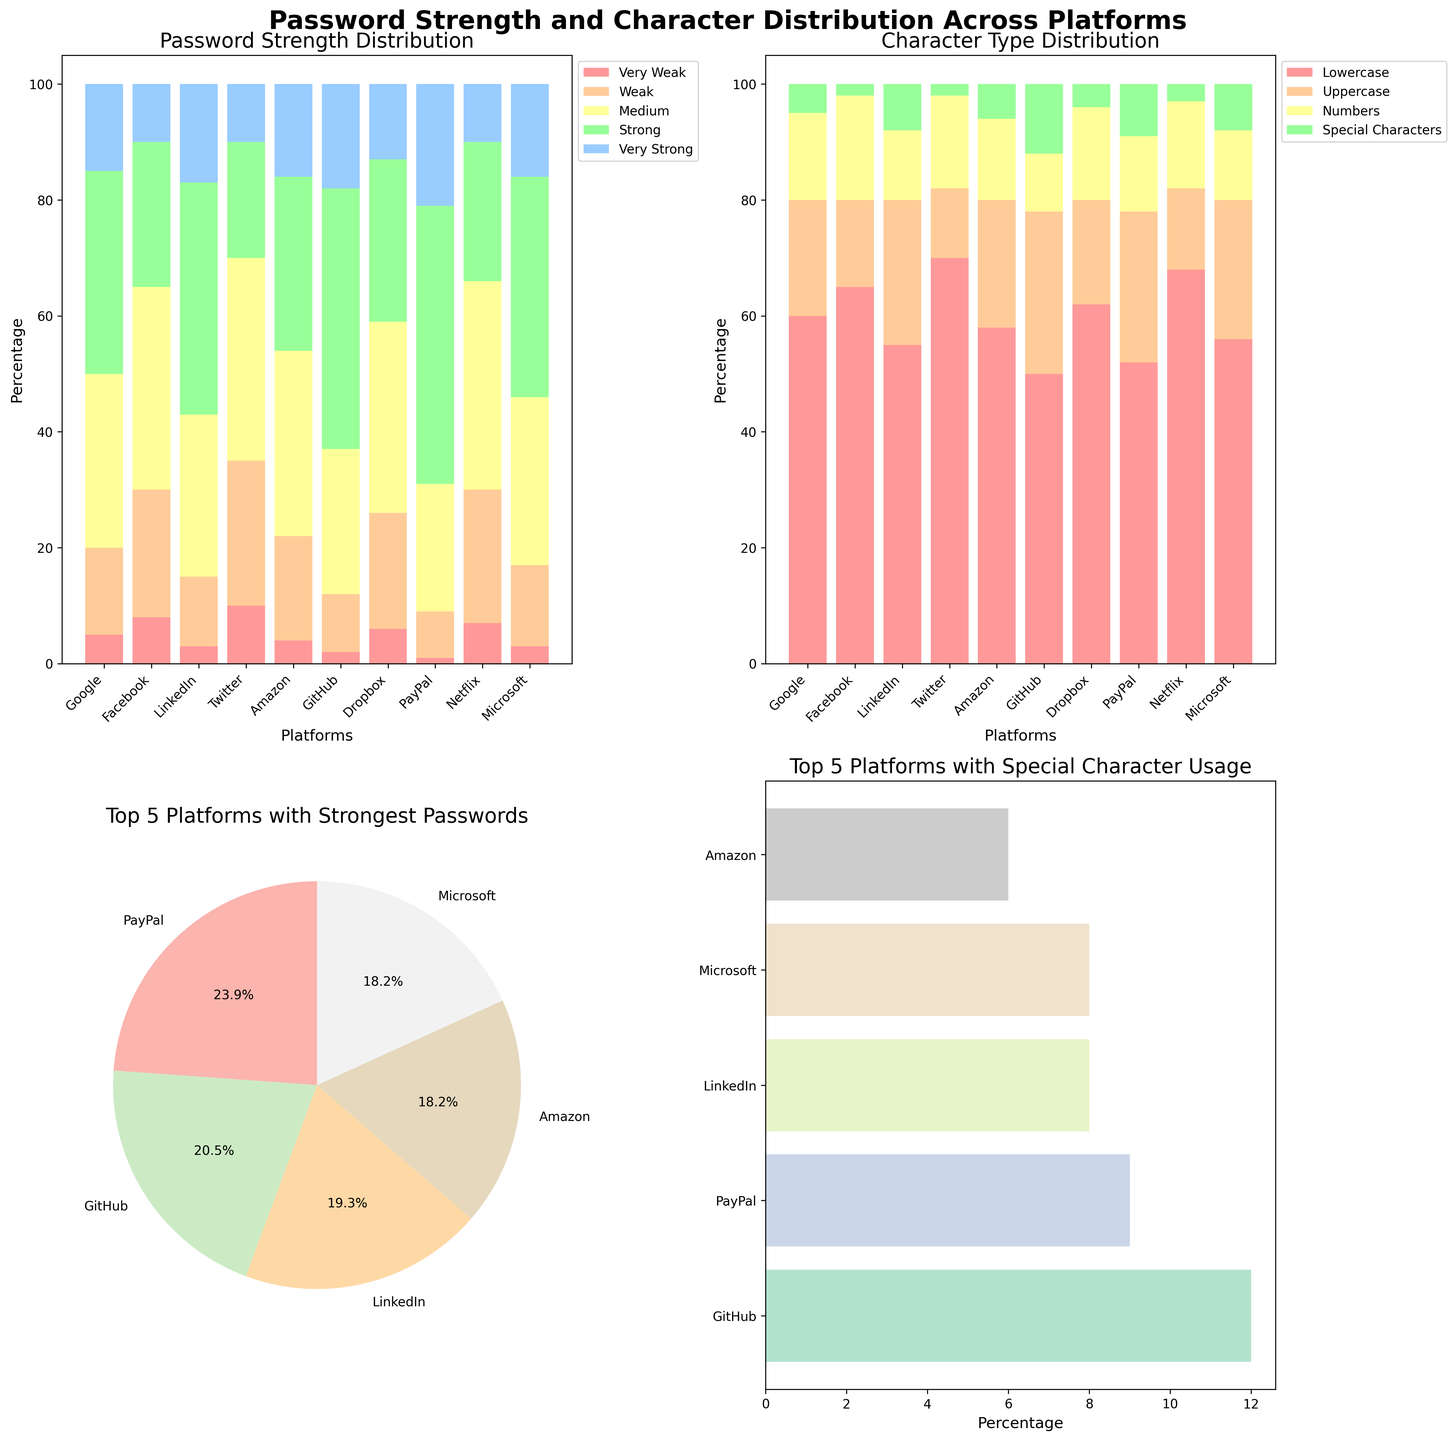What percentage of passwords on Google are considered 'Very Strong'? By looking at the bar labeled 'Google' in the 'Password Strength Distribution' plot, the 'Very Strong' section is around 15%.
Answer: 15% Which platform has the highest percentage of 'Uppercase' character usage in passwords? By viewing the 'Character Type Distribution' plot, 'Google' has the tallest bar segment for 'Uppercase' characters, accounting for 28%.
Answer: GitHub Among all platforms, which one shows the highest usage of 'Special Characters' in their passwords? In the 'Character Type Distribution' plot, GitHub has the tallest bar segment for 'Special Characters' usage, approximately 12%.
Answer: GitHub Compare the percentage of 'Strong' passwords on LinkedIn and Amazon. Which platform has a higher percentage and by how much? In the 'Password Strength Distribution' plot, LinkedIn has around 40% 'Strong' passwords, compared to Amazon which has around 30%. The difference is 40% - 30% = 10%.
Answer: LinkedIn, by 10% Which five platforms have the highest percentage of 'Very Strong' passwords? Looking at the pie chart in the bottom left subplot titled 'Top 5 Platforms with Strongest Passwords', the platforms are PayPal, LinkedIn, Microsoft, GitHub, and Amazon.
Answer: PayPal, LinkedIn, Microsoft, GitHub, Amazon What is the combined percentage of 'Very Weak' and 'Weak' passwords on Twitter? In the 'Password Strength Distribution' plot, Twitter's 'Very Weak' is 10% and 'Weak' is 25%. The combined percentage is 10% + 25% = 35%.
Answer: 35% What percentage of passwords on Facebook do not contain 'Special Characters'? In the 'Character Type Distribution' plot, 'Special Characters' on Facebook is around 2%, so the percentage without 'Special Characters' is 100% - 2% = 98%.
Answer: 98% Which platform has the lowest usage of 'Numbers' in their passwords? By noticing the 'Character Type Distribution' plot, PayPal has the smallest bar segment for 'Numbers', approximately 13%.
Answer: PayPal Which platform has the second highest usage of 'Lowercase' characters among all platforms? In the 'Character Type Distribution' plot, the second highest 'Lowercase' usage is on Facebook, which is around 65%.
Answer: Facebook 